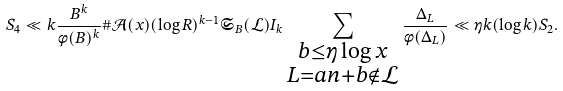<formula> <loc_0><loc_0><loc_500><loc_500>S _ { 4 } \ll k \frac { B ^ { k } } { \phi ( B ) ^ { k } } \# \mathcal { A } ( x ) ( \log { R } ) ^ { k - 1 } \mathfrak { S } _ { B } ( \mathcal { L } ) I _ { k } \sum _ { \substack { b \leq \eta \log { x } \\ L = a n + b \notin \mathcal { L } } } \frac { \Delta _ { L } } { \phi ( \Delta _ { L } ) } \ll \eta k ( \log { k } ) S _ { 2 } .</formula> 